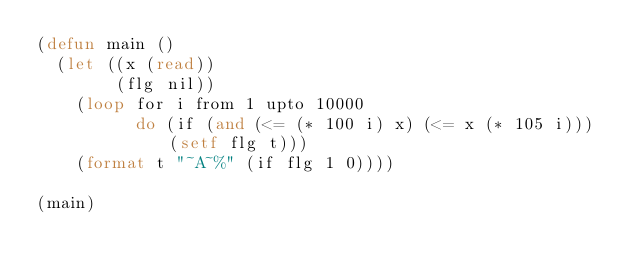<code> <loc_0><loc_0><loc_500><loc_500><_Lisp_>(defun main ()
  (let ((x (read))
        (flg nil))
    (loop for i from 1 upto 10000
          do (if (and (<= (* 100 i) x) (<= x (* 105 i))) (setf flg t)))
    (format t "~A~%" (if flg 1 0))))

(main)
</code> 